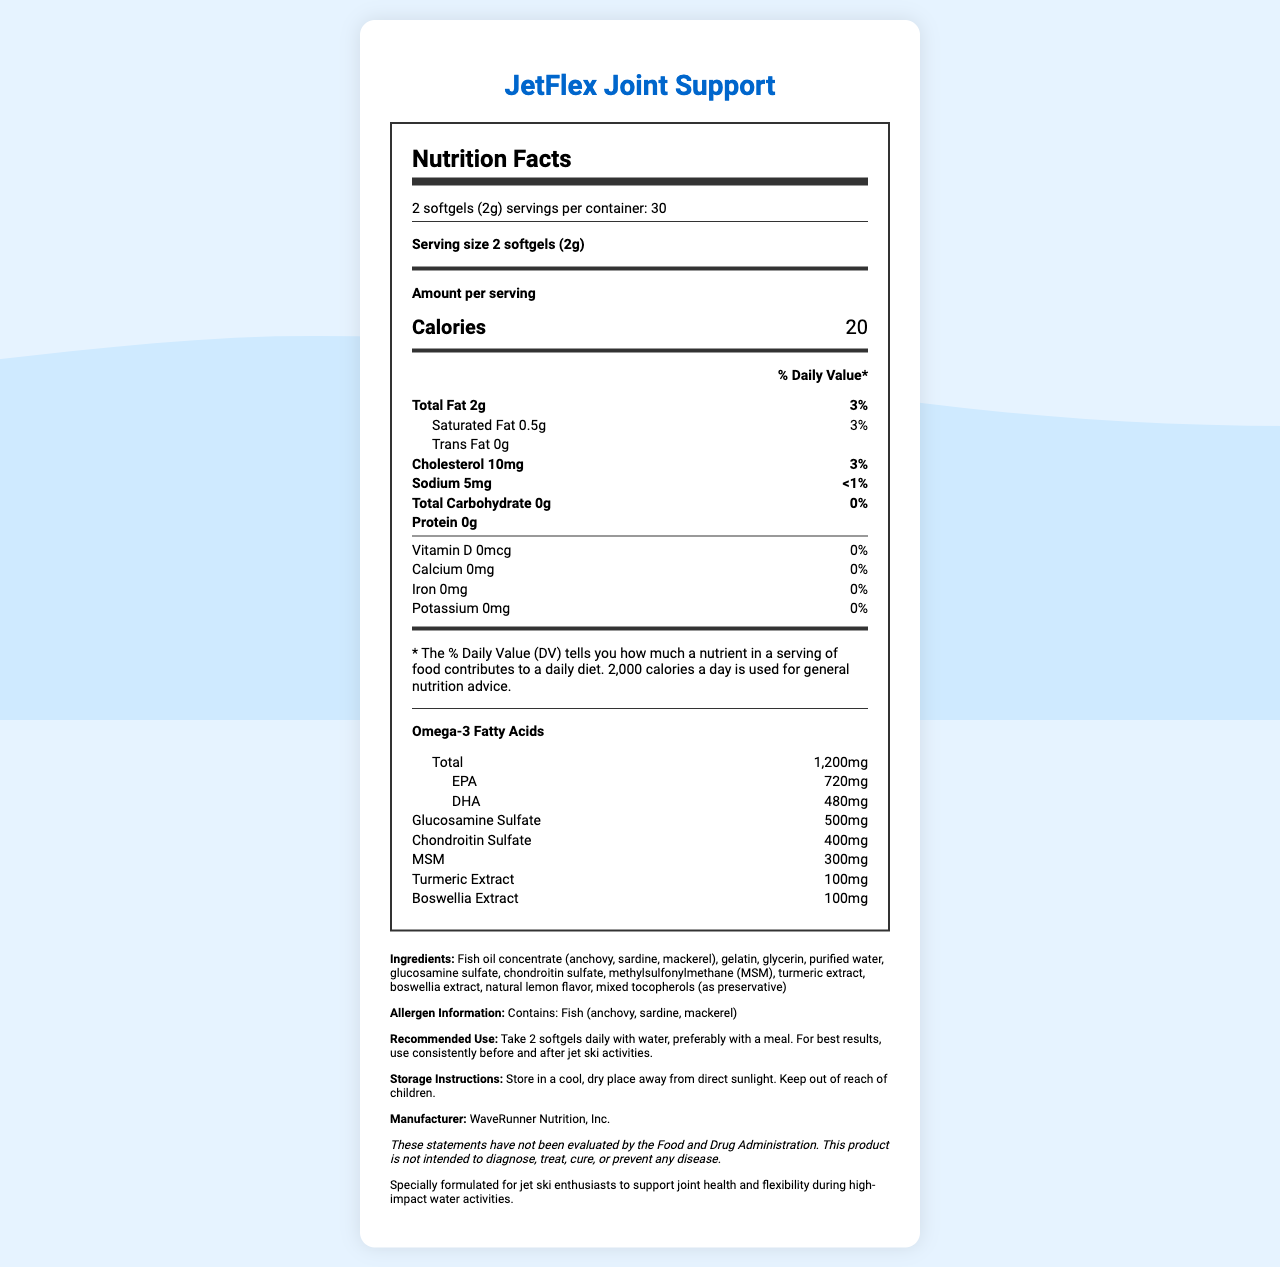what is the serving size? The serving size is stated clearly at the top of the nutrition label section.
Answer: 2 softgels (2g) how many calories are in each serving? The amount of calories per serving is listed in the "Amount per serving" section as 20.
Answer: 20 what is the total fat content per serving? The nutrition label clearly states that the total fat content per serving is 2g.
Answer: 2g what are the ingredients of JetFlex Joint Support? The ingredient list is detailed in the additional information section.
Answer: Fish oil concentrate (anchovy, sardine, mackerel), gelatin, glycerin, purified water, glucosamine sulfate, chondroitin sulfate, methylsulfonylmethane (MSM), turmeric extract, boswellia extract, natural lemon flavor, mixed tocopherols (as preservative) how much glucosamine sulfate is in each serving? The amount of glucosamine sulfate is listed in the nutrition details as 500mg.
Answer: 500mg how often should you take JetFlex Joint Support for best results? A. Once a day B. Twice a day C. Three times a day D. Four times a day The recommended use suggests taking 2 softgels daily, implying twice a day.
Answer: B. Twice a day what type of fish is contained in JetFlex Joint Support? A. Anchovy, sardine, tuna B. Anchovy, mackerel, sardine C. Tuna, salmon, mackerel D. Salmon, mackerel, cod The ingredients include fish oil concentrate from anchovy, sardine, and mackerel.
Answer: B. Anchovy, mackerel, sardine does this product contain any cholesterol? The nutrition facts state that there are 10mg of cholesterol per serving.
Answer: Yes is this supplement recommended to take with or without food? The recommended use suggests taking the softgels with water, preferably with a meal.
Answer: With food cannot be answered The document does not provide any pricing information, so the price cannot be determined.
Answer: What is the price of JetFlex Joint Support? summarize the document The document is comprehensively detailed with nutritional information, ingredient list, usage instructions, and special notes related to joint health for jet ski enthusiasts.
Answer: The document provides the nutrition facts, ingredients, and recommended use for JetFlex Joint Support, an omega-3 supplement aimed at supporting joint health for jet ski users. Each serving size is 2 softgels, containing 20 calories, 2g of total fat, and a variety of compounds including omega-3 fatty acids, glucosamine sulfate, and chondroitin sulfate. The supplement contains fish oil and other ingredients to support joint flexibility. It is recommended to be taken twice daily with a meal. 